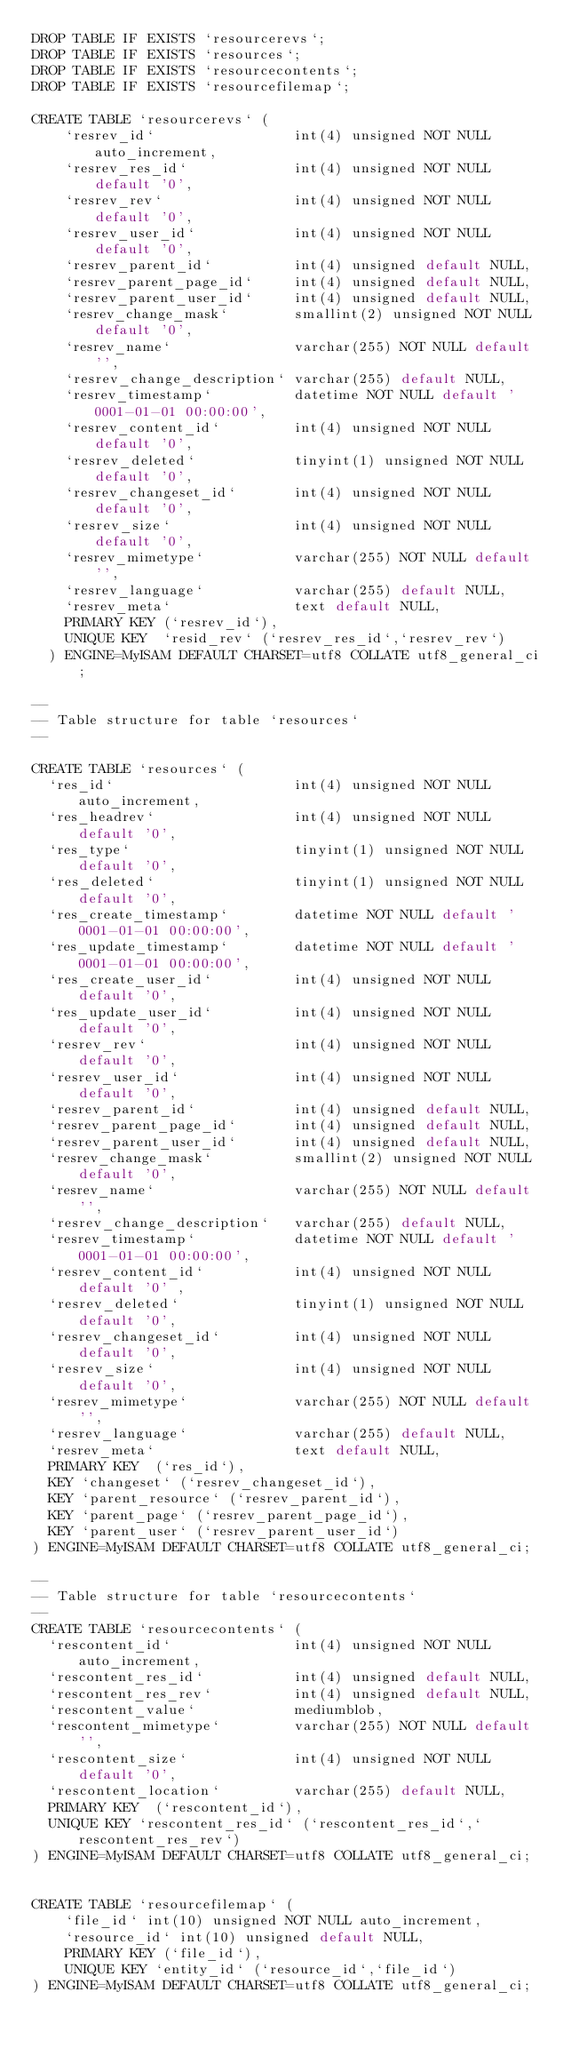Convert code to text. <code><loc_0><loc_0><loc_500><loc_500><_SQL_>DROP TABLE IF EXISTS `resourcerevs`;
DROP TABLE IF EXISTS `resources`;
DROP TABLE IF EXISTS `resourcecontents`;
DROP TABLE IF EXISTS `resourcefilemap`;

CREATE TABLE `resourcerevs` (                                      
    `resrev_id`                 int(4) unsigned NOT NULL auto_increment,                       
    `resrev_res_id`             int(4) unsigned NOT NULL default '0',                  
    `resrev_rev`                int(4) unsigned NOT NULL default '0',                          
    `resrev_user_id`            int(4) unsigned NOT NULL default '0',
    `resrev_parent_id`          int(4) unsigned default NULL,
    `resrev_parent_page_id`     int(4) unsigned default NULL,
    `resrev_parent_user_id`     int(4) unsigned default NULL,
    `resrev_change_mask`        smallint(2) unsigned NOT NULL default '0',                 
    `resrev_name`               varchar(255) NOT NULL default '',             
    `resrev_change_description` varchar(255) default NULL,             
    `resrev_timestamp`          datetime NOT NULL default '0001-01-01 00:00:00',
    `resrev_content_id`         int(4) unsigned NOT NULL default '0',
    `resrev_deleted`            tinyint(1) unsigned NOT NULL default '0',  
    `resrev_changeset_id`	    int(4) unsigned NOT NULL default '0',
    `resrev_size`               int(4) unsigned NOT NULL default '0',                     
    `resrev_mimetype`           varchar(255) NOT NULL default '',                    
    `resrev_language`           varchar(255) default NULL,
    `resrev_meta`	            text default NULL,
    PRIMARY KEY (`resrev_id`),
    UNIQUE KEY  `resid_rev` (`resrev_res_id`,`resrev_rev`)
  ) ENGINE=MyISAM DEFAULT CHARSET=utf8 COLLATE utf8_general_ci;

--
-- Table structure for table `resources`
--

CREATE TABLE `resources` (                                      
  `res_id`                      int(4) unsigned NOT NULL auto_increment,
  `res_headrev`                 int(4) unsigned NOT NULL default '0',
  `res_type`                    tinyint(1) unsigned NOT NULL default '0',
  `res_deleted`                 tinyint(1) unsigned NOT NULL default '0',
  `res_create_timestamp`        datetime NOT NULL default '0001-01-01 00:00:00',
  `res_update_timestamp`        datetime NOT NULL default '0001-01-01 00:00:00',
  `res_create_user_id`          int(4) unsigned NOT NULL default '0',
  `res_update_user_id`          int(4) unsigned NOT NULL default '0',
  `resrev_rev`                  int(4) unsigned NOT NULL default '0',                          
  `resrev_user_id`              int(4) unsigned NOT NULL default '0',                  
  `resrev_parent_id`            int(4) unsigned default NULL,                  
  `resrev_parent_page_id`       int(4) unsigned default NULL,
  `resrev_parent_user_id`       int(4) unsigned default NULL,
  `resrev_change_mask`          smallint(2) unsigned NOT NULL default '0',                 
  `resrev_name`                 varchar(255) NOT NULL default '',             
  `resrev_change_description`   varchar(255) default NULL,             
  `resrev_timestamp`            datetime NOT NULL default '0001-01-01 00:00:00',
  `resrev_content_id`           int(4) unsigned NOT NULL default '0' ,
  `resrev_deleted`              tinyint(1) unsigned NOT NULL default '0',  
  `resrev_changeset_id`         int(4) unsigned NOT NULL default '0',
  `resrev_size`                 int(4) unsigned NOT NULL default '0',                     
  `resrev_mimetype`             varchar(255) NOT NULL default '',                    
  `resrev_language`             varchar(255) default NULL,
  `resrev_meta`					text default NULL,
  PRIMARY KEY  (`res_id`),
  KEY `changeset` (`resrev_changeset_id`),
  KEY `parent_resource` (`resrev_parent_id`),
  KEY `parent_page` (`resrev_parent_page_id`),
  KEY `parent_user` (`resrev_parent_user_id`)
) ENGINE=MyISAM DEFAULT CHARSET=utf8 COLLATE utf8_general_ci;

--
-- Table structure for table `resourcecontents`
--
CREATE TABLE `resourcecontents` (                                            
  `rescontent_id`               int(4) unsigned NOT NULL auto_increment,                   
  `rescontent_res_id`           int(4) unsigned default NULL,                              
  `rescontent_res_rev`          int(4) unsigned default NULL,                        
  `rescontent_value`            mediumblob,
  `rescontent_mimetype`         varchar(255) NOT NULL default '',
  `rescontent_size`             int(4) unsigned NOT NULL default '0',
  `rescontent_location`         varchar(255) default NULL,                           
  PRIMARY KEY  (`rescontent_id`),                                            
  UNIQUE KEY `rescontent_res_id` (`rescontent_res_id`,`rescontent_res_rev`)  
) ENGINE=MyISAM DEFAULT CHARSET=utf8 COLLATE utf8_general_ci;


CREATE TABLE `resourcefilemap` (
	`file_id` int(10) unsigned NOT NULL auto_increment,
	`resource_id` int(10) unsigned default NULL,
	PRIMARY KEY (`file_id`),
	UNIQUE KEY `entity_id` (`resource_id`,`file_id`)
) ENGINE=MyISAM DEFAULT CHARSET=utf8 COLLATE utf8_general_ci;
</code> 